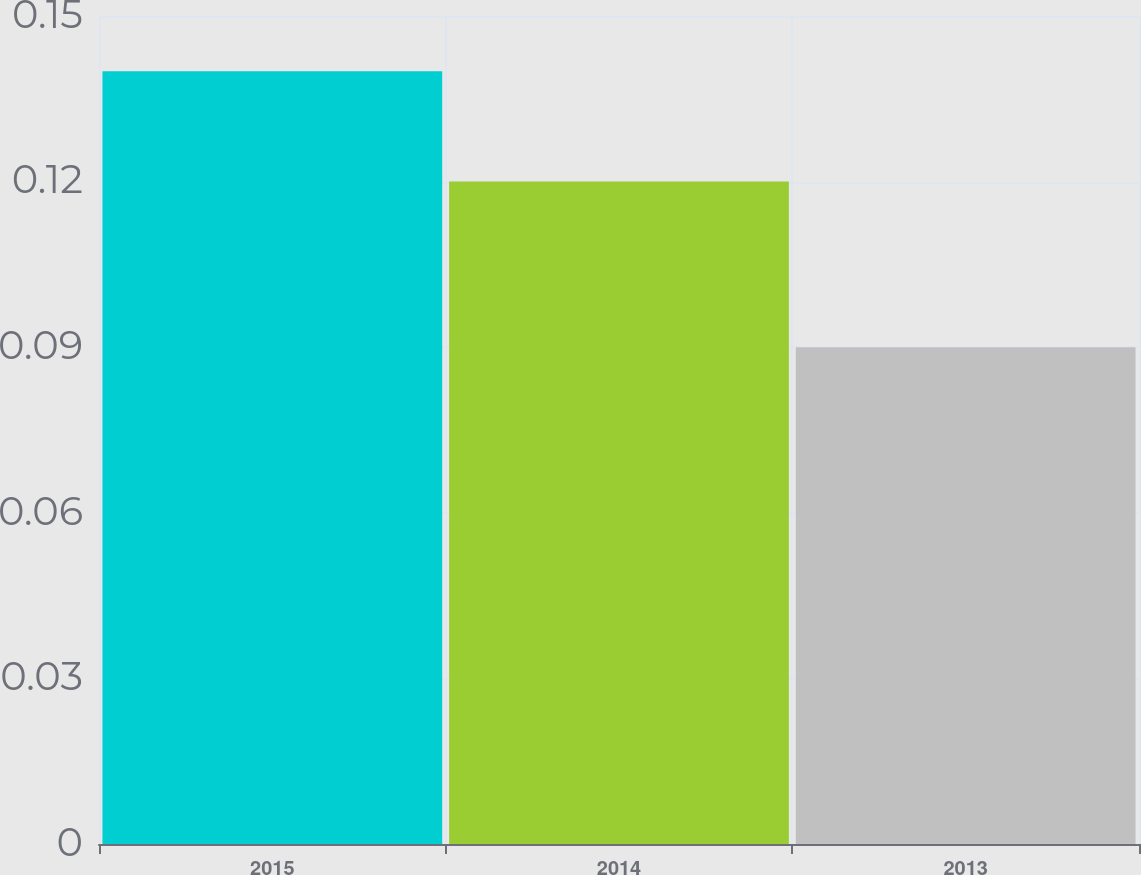<chart> <loc_0><loc_0><loc_500><loc_500><bar_chart><fcel>2015<fcel>2014<fcel>2013<nl><fcel>0.14<fcel>0.12<fcel>0.09<nl></chart> 